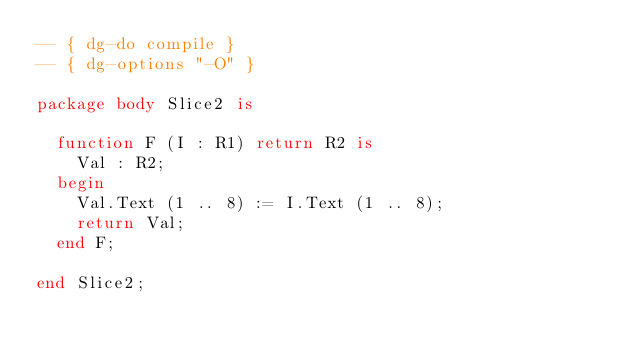Convert code to text. <code><loc_0><loc_0><loc_500><loc_500><_Ada_>-- { dg-do compile }
-- { dg-options "-O" }

package body Slice2 is

  function F (I : R1) return R2 is
    Val : R2;
  begin
    Val.Text (1 .. 8) := I.Text (1 .. 8);
    return Val;
  end F;

end Slice2;
</code> 